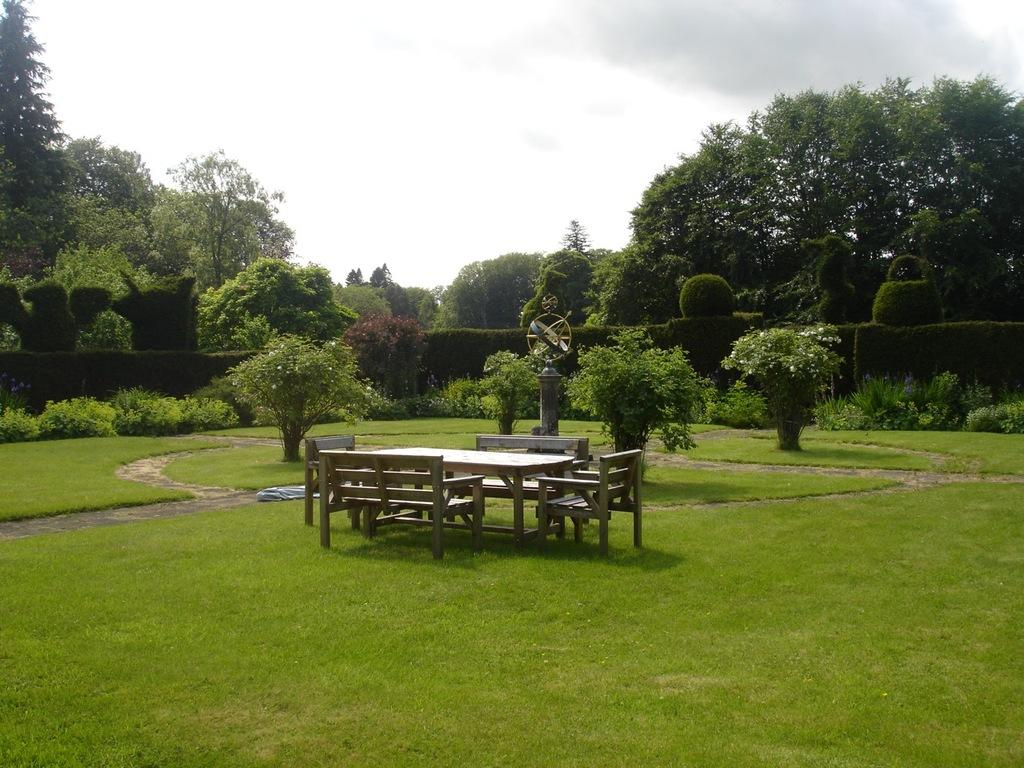What type of furniture is present in the image? There is a table and chairs in the image. What can be seen in the background of the image? There are trees and the sky visible in the background of the image. What language is being taught in the image? There is no indication of language teaching in the image. 